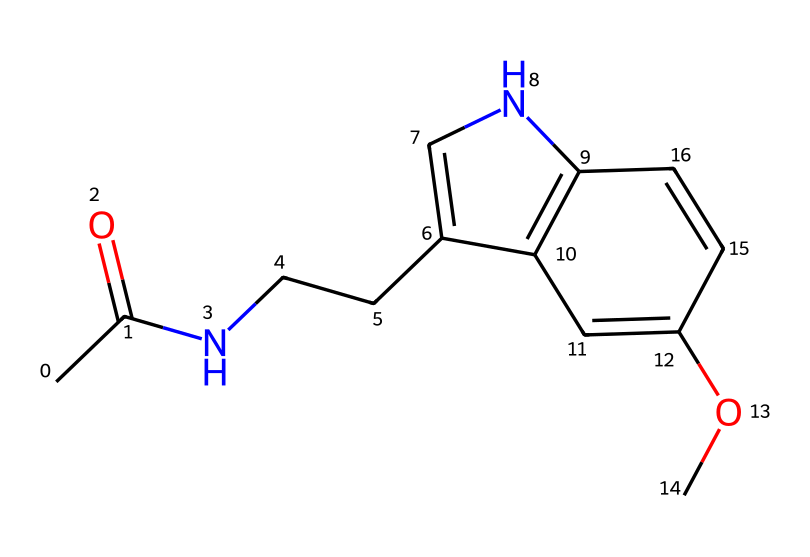How many carbon atoms are present in the structure of melatonin? By analyzing the SMILES representation, we count the carbon symbols (C) present. The structure includes several carbons, and upon tallying, we find there are 13 carbon atoms.
Answer: 13 What functional group is present in melatonin that indicates it is an amide? The presence of a carbonyl group (C=O) attached to a nitrogen (N) signifies the amide functional group. This can be identified in the structure's components where the nitrogen is directly bonded to the carbon that has a double bond with oxygen.
Answer: amide What is the role of melatonin related to sleep patterns? Melatonin is known primarily for its role in regulating sleep, specifically in signaling the body when to sleep and maintaining circadian rhythms. This is crucial for esports players who may have irregular sleep schedules due to gaming commitments.
Answer: regulates sleep What type of chemical is melatonin classified as? Melatonin is classified as a hormone due to its biological activity and function within the endocrine system. Hormones are signaling molecules that help regulate physiological processes.
Answer: hormone What influence does melatonin supplementation have on esports players' performance? Melatonin supplementation can improve sleep quality and duration, reducing fatigue and increasing cognitive function during gameplay. This is particularly beneficial for esports players who require alertness and focus.
Answer: improves performance 